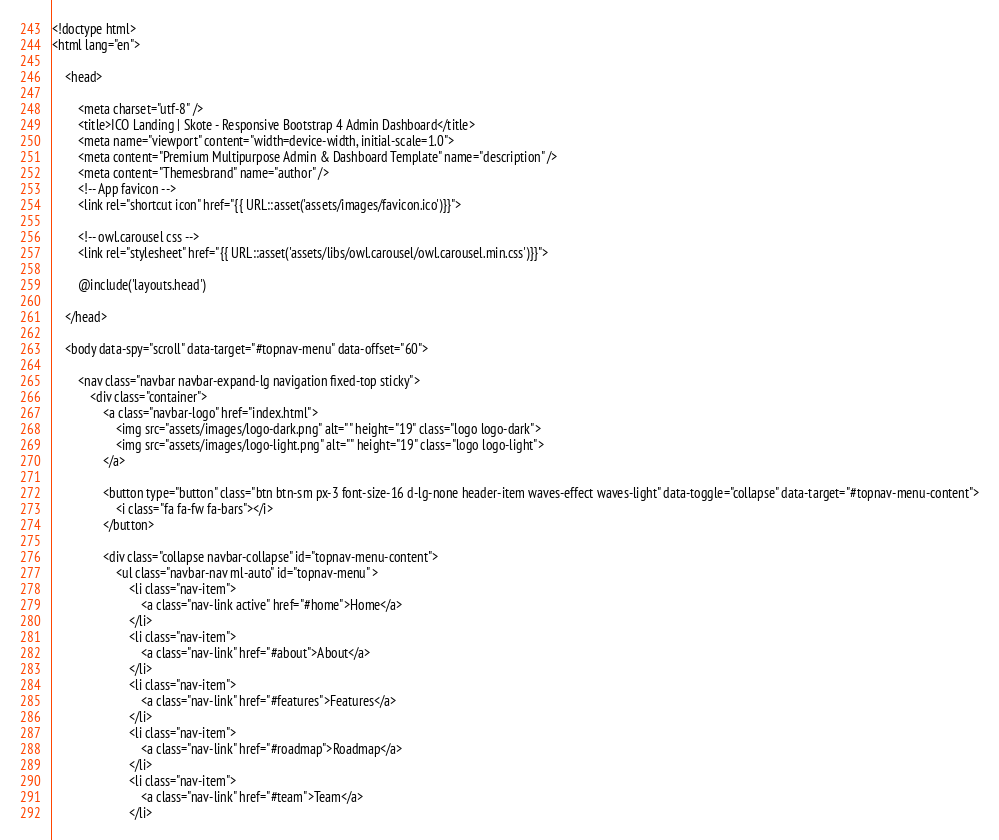Convert code to text. <code><loc_0><loc_0><loc_500><loc_500><_PHP_><!doctype html>
<html lang="en">

    <head>
        
        <meta charset="utf-8" />
        <title>ICO Landing | Skote - Responsive Bootstrap 4 Admin Dashboard</title>
        <meta name="viewport" content="width=device-width, initial-scale=1.0">
        <meta content="Premium Multipurpose Admin & Dashboard Template" name="description" />
        <meta content="Themesbrand" name="author" />
        <!-- App favicon -->
        <link rel="shortcut icon" href="{{ URL::asset('assets/images/favicon.ico')}}">

        <!-- owl.carousel css -->
        <link rel="stylesheet" href="{{ URL::asset('assets/libs/owl.carousel/owl.carousel.min.css')}}">

        @include('layouts.head')

    </head>

    <body data-spy="scroll" data-target="#topnav-menu" data-offset="60">

        <nav class="navbar navbar-expand-lg navigation fixed-top sticky">
            <div class="container">
                <a class="navbar-logo" href="index.html">
                    <img src="assets/images/logo-dark.png" alt="" height="19" class="logo logo-dark">
                    <img src="assets/images/logo-light.png" alt="" height="19" class="logo logo-light">
                </a>

                <button type="button" class="btn btn-sm px-3 font-size-16 d-lg-none header-item waves-effect waves-light" data-toggle="collapse" data-target="#topnav-menu-content">
                    <i class="fa fa-fw fa-bars"></i>
                </button>
              
                <div class="collapse navbar-collapse" id="topnav-menu-content">
                    <ul class="navbar-nav ml-auto" id="topnav-menu" >
                        <li class="nav-item">
                            <a class="nav-link active" href="#home">Home</a>
                        </li>
                        <li class="nav-item">
                            <a class="nav-link" href="#about">About</a>
                        </li>
                        <li class="nav-item">
                            <a class="nav-link" href="#features">Features</a>
                        </li>
                        <li class="nav-item">
                            <a class="nav-link" href="#roadmap">Roadmap</a>
                        </li>
                        <li class="nav-item">
                            <a class="nav-link" href="#team">Team</a>
                        </li></code> 